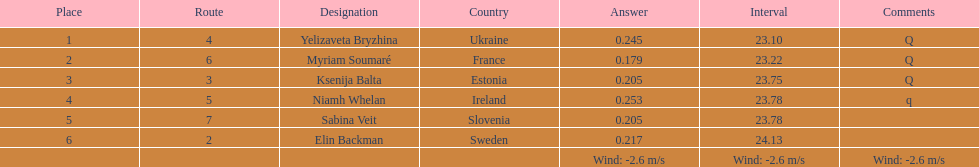The variation between yelizaveta bryzhina's time and ksenija balta's time? 0.65. 